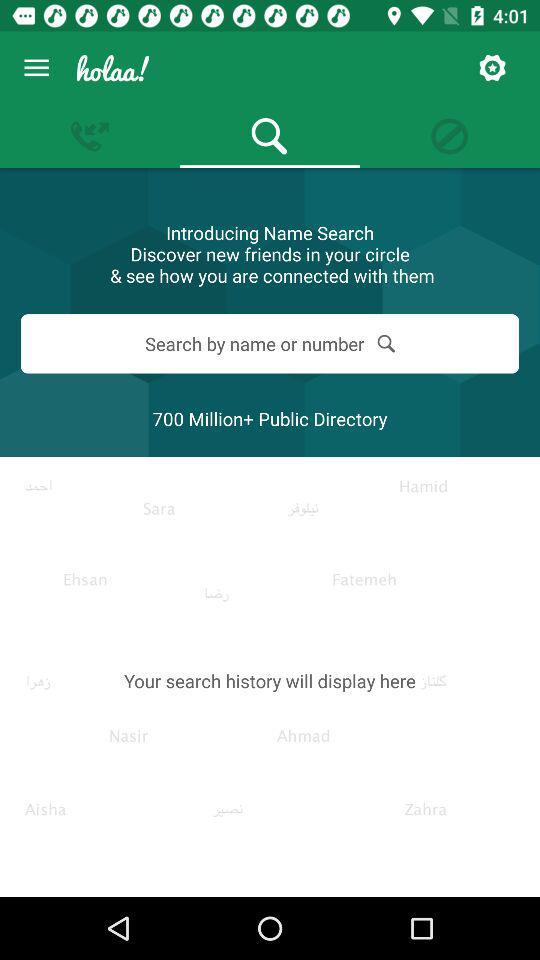What is the name of the application? The name of the application is "holaa!". 